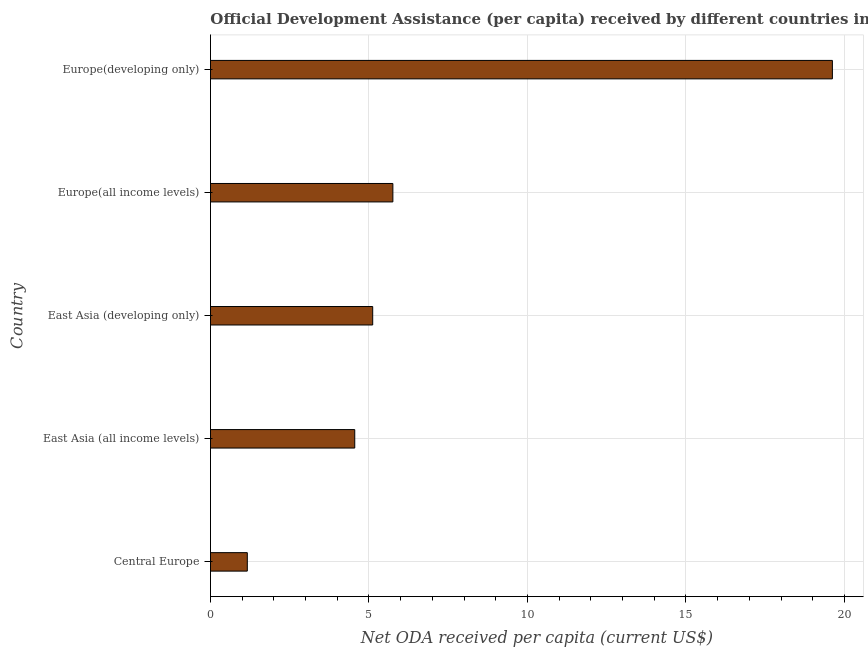Does the graph contain any zero values?
Provide a succinct answer. No. What is the title of the graph?
Keep it short and to the point. Official Development Assistance (per capita) received by different countries in the year 2005. What is the label or title of the X-axis?
Your response must be concise. Net ODA received per capita (current US$). What is the label or title of the Y-axis?
Your answer should be very brief. Country. What is the net oda received per capita in Central Europe?
Offer a terse response. 1.16. Across all countries, what is the maximum net oda received per capita?
Ensure brevity in your answer.  19.62. Across all countries, what is the minimum net oda received per capita?
Your response must be concise. 1.16. In which country was the net oda received per capita maximum?
Offer a very short reply. Europe(developing only). In which country was the net oda received per capita minimum?
Provide a short and direct response. Central Europe. What is the sum of the net oda received per capita?
Your answer should be very brief. 36.2. What is the difference between the net oda received per capita in Central Europe and East Asia (all income levels)?
Your response must be concise. -3.39. What is the average net oda received per capita per country?
Offer a very short reply. 7.24. What is the median net oda received per capita?
Provide a short and direct response. 5.12. In how many countries, is the net oda received per capita greater than 19 US$?
Make the answer very short. 1. What is the ratio of the net oda received per capita in Europe(all income levels) to that in Europe(developing only)?
Provide a short and direct response. 0.29. What is the difference between the highest and the second highest net oda received per capita?
Make the answer very short. 13.87. Is the sum of the net oda received per capita in Europe(all income levels) and Europe(developing only) greater than the maximum net oda received per capita across all countries?
Make the answer very short. Yes. What is the difference between the highest and the lowest net oda received per capita?
Make the answer very short. 18.46. How many bars are there?
Ensure brevity in your answer.  5. What is the difference between two consecutive major ticks on the X-axis?
Ensure brevity in your answer.  5. What is the Net ODA received per capita (current US$) in Central Europe?
Keep it short and to the point. 1.16. What is the Net ODA received per capita (current US$) of East Asia (all income levels)?
Offer a very short reply. 4.55. What is the Net ODA received per capita (current US$) in East Asia (developing only)?
Keep it short and to the point. 5.12. What is the Net ODA received per capita (current US$) of Europe(all income levels)?
Keep it short and to the point. 5.75. What is the Net ODA received per capita (current US$) of Europe(developing only)?
Make the answer very short. 19.62. What is the difference between the Net ODA received per capita (current US$) in Central Europe and East Asia (all income levels)?
Make the answer very short. -3.39. What is the difference between the Net ODA received per capita (current US$) in Central Europe and East Asia (developing only)?
Provide a short and direct response. -3.96. What is the difference between the Net ODA received per capita (current US$) in Central Europe and Europe(all income levels)?
Offer a terse response. -4.59. What is the difference between the Net ODA received per capita (current US$) in Central Europe and Europe(developing only)?
Ensure brevity in your answer.  -18.46. What is the difference between the Net ODA received per capita (current US$) in East Asia (all income levels) and East Asia (developing only)?
Ensure brevity in your answer.  -0.57. What is the difference between the Net ODA received per capita (current US$) in East Asia (all income levels) and Europe(all income levels)?
Ensure brevity in your answer.  -1.2. What is the difference between the Net ODA received per capita (current US$) in East Asia (all income levels) and Europe(developing only)?
Your answer should be very brief. -15.07. What is the difference between the Net ODA received per capita (current US$) in East Asia (developing only) and Europe(all income levels)?
Ensure brevity in your answer.  -0.64. What is the difference between the Net ODA received per capita (current US$) in East Asia (developing only) and Europe(developing only)?
Your answer should be very brief. -14.5. What is the difference between the Net ODA received per capita (current US$) in Europe(all income levels) and Europe(developing only)?
Give a very brief answer. -13.86. What is the ratio of the Net ODA received per capita (current US$) in Central Europe to that in East Asia (all income levels)?
Provide a short and direct response. 0.26. What is the ratio of the Net ODA received per capita (current US$) in Central Europe to that in East Asia (developing only)?
Ensure brevity in your answer.  0.23. What is the ratio of the Net ODA received per capita (current US$) in Central Europe to that in Europe(all income levels)?
Offer a terse response. 0.2. What is the ratio of the Net ODA received per capita (current US$) in Central Europe to that in Europe(developing only)?
Make the answer very short. 0.06. What is the ratio of the Net ODA received per capita (current US$) in East Asia (all income levels) to that in East Asia (developing only)?
Your answer should be very brief. 0.89. What is the ratio of the Net ODA received per capita (current US$) in East Asia (all income levels) to that in Europe(all income levels)?
Keep it short and to the point. 0.79. What is the ratio of the Net ODA received per capita (current US$) in East Asia (all income levels) to that in Europe(developing only)?
Provide a succinct answer. 0.23. What is the ratio of the Net ODA received per capita (current US$) in East Asia (developing only) to that in Europe(all income levels)?
Provide a succinct answer. 0.89. What is the ratio of the Net ODA received per capita (current US$) in East Asia (developing only) to that in Europe(developing only)?
Provide a succinct answer. 0.26. What is the ratio of the Net ODA received per capita (current US$) in Europe(all income levels) to that in Europe(developing only)?
Provide a succinct answer. 0.29. 